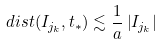<formula> <loc_0><loc_0><loc_500><loc_500>d i s t ( I _ { j _ { k } } , t _ { * } ) \lesssim \frac { 1 } { a } \left | I _ { j _ { k } } \right |</formula> 